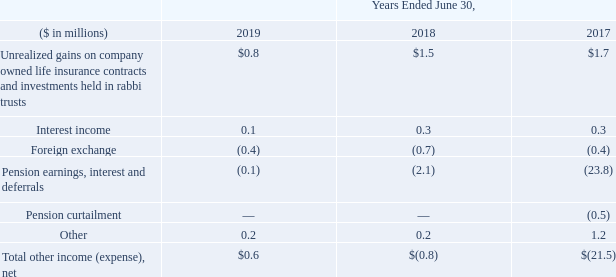18. Other Income (Expense), Net
Other income (expense), net consists of the following:
What was the amount of Interest income in 2019?
Answer scale should be: million. 0.1. What was the Total other income (expense), net in 2018?
Answer scale should be: million. $(0.8). In which years is total Other Income (Expense), Net calculated? 2019, 2018, 2017. In which year was Other the largest? 1.2>0.2
Answer: 2017. What was the change in interest income in 2019 from 2018?
Answer scale should be: million. 0.1-0.3
Answer: -0.2. What was the percentage change in interest income in 2019 from 2018?
Answer scale should be: percent. (0.1-0.3)/0.3
Answer: -66.67. 